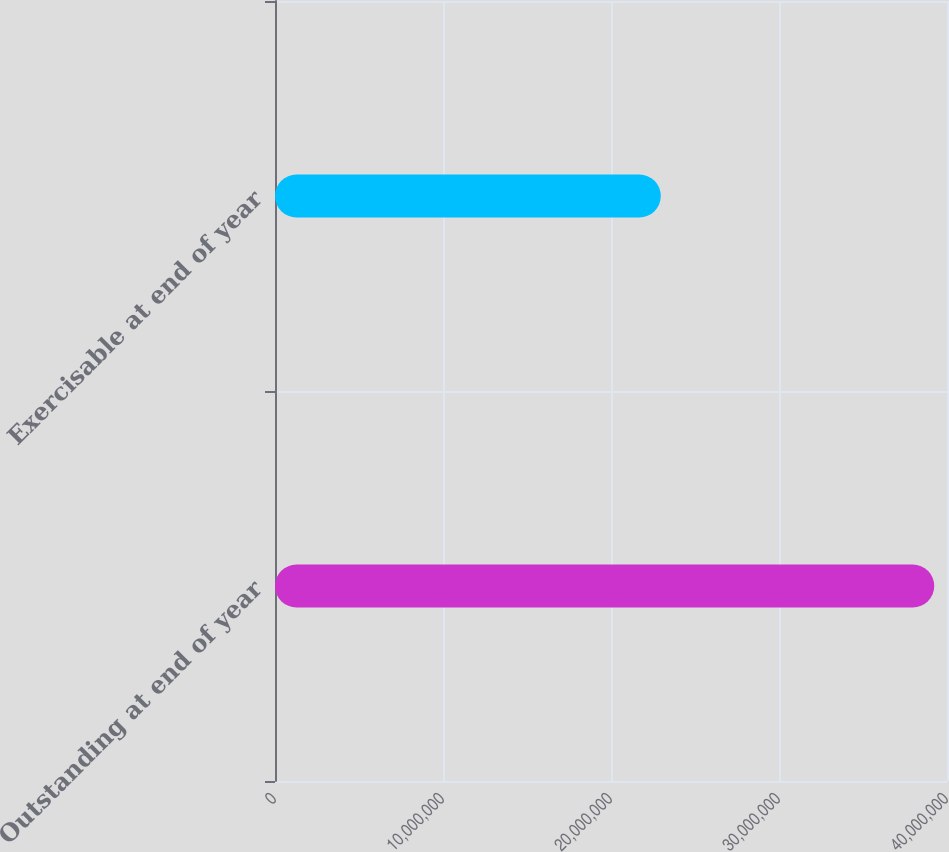<chart> <loc_0><loc_0><loc_500><loc_500><bar_chart><fcel>Outstanding at end of year<fcel>Exercisable at end of year<nl><fcel>3.92397e+07<fcel>2.2964e+07<nl></chart> 